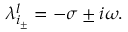<formula> <loc_0><loc_0><loc_500><loc_500>\begin{array} { r } { \lambda _ { i _ { \pm } } ^ { l } = - \sigma \pm i \omega . } \end{array}</formula> 